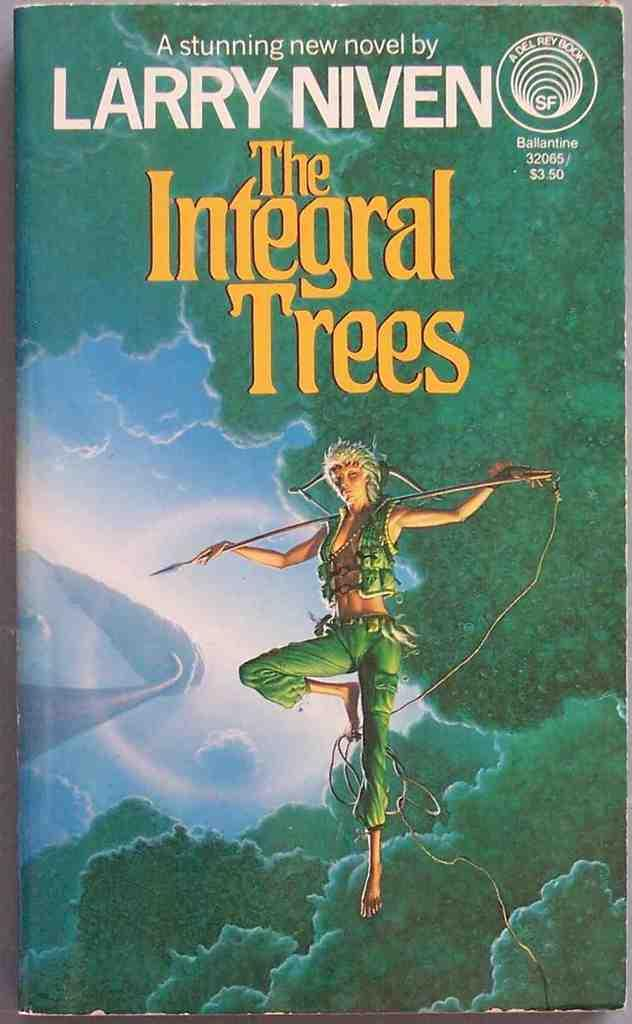<image>
Give a short and clear explanation of the subsequent image. The cover for the book The integral Trees by Larry Niven. 